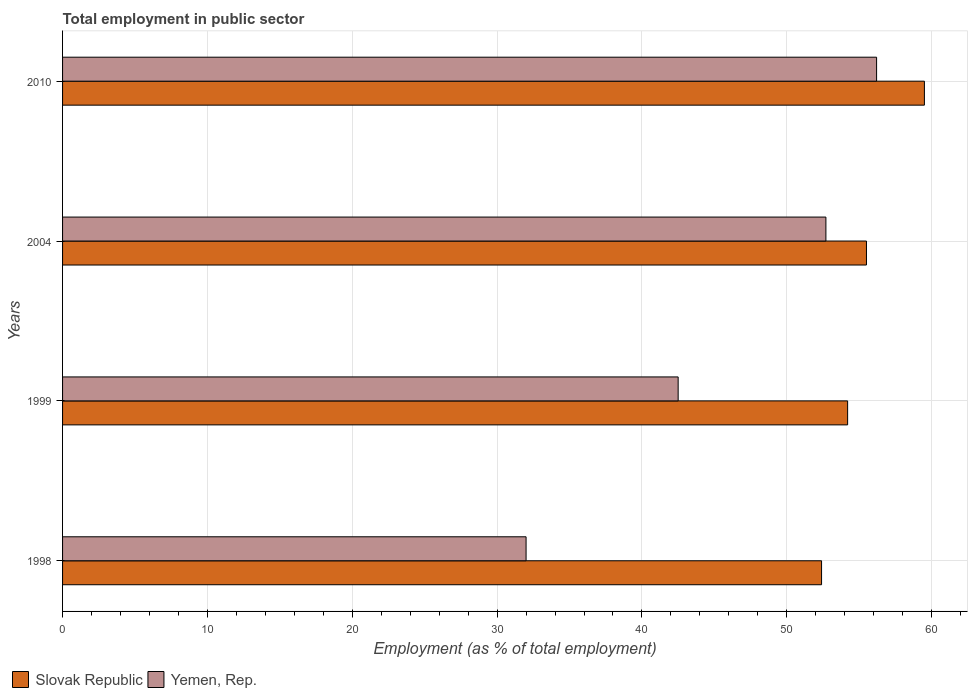How many groups of bars are there?
Your response must be concise. 4. Are the number of bars per tick equal to the number of legend labels?
Offer a terse response. Yes. How many bars are there on the 3rd tick from the bottom?
Ensure brevity in your answer.  2. What is the label of the 2nd group of bars from the top?
Provide a succinct answer. 2004. What is the employment in public sector in Slovak Republic in 2004?
Provide a succinct answer. 55.5. Across all years, what is the maximum employment in public sector in Slovak Republic?
Offer a very short reply. 59.5. Across all years, what is the minimum employment in public sector in Slovak Republic?
Keep it short and to the point. 52.4. In which year was the employment in public sector in Yemen, Rep. minimum?
Offer a very short reply. 1998. What is the total employment in public sector in Yemen, Rep. in the graph?
Your answer should be very brief. 183.4. What is the difference between the employment in public sector in Slovak Republic in 1999 and that in 2004?
Make the answer very short. -1.3. What is the difference between the employment in public sector in Yemen, Rep. in 2004 and the employment in public sector in Slovak Republic in 2010?
Give a very brief answer. -6.8. What is the average employment in public sector in Slovak Republic per year?
Offer a very short reply. 55.4. In the year 1998, what is the difference between the employment in public sector in Slovak Republic and employment in public sector in Yemen, Rep.?
Provide a succinct answer. 20.4. What is the ratio of the employment in public sector in Slovak Republic in 1998 to that in 2004?
Your answer should be compact. 0.94. What is the difference between the highest and the lowest employment in public sector in Slovak Republic?
Keep it short and to the point. 7.1. In how many years, is the employment in public sector in Slovak Republic greater than the average employment in public sector in Slovak Republic taken over all years?
Keep it short and to the point. 2. Is the sum of the employment in public sector in Yemen, Rep. in 1999 and 2010 greater than the maximum employment in public sector in Slovak Republic across all years?
Give a very brief answer. Yes. What does the 2nd bar from the top in 1998 represents?
Your response must be concise. Slovak Republic. What does the 1st bar from the bottom in 2010 represents?
Your answer should be very brief. Slovak Republic. How many years are there in the graph?
Give a very brief answer. 4. What is the difference between two consecutive major ticks on the X-axis?
Your answer should be very brief. 10. Are the values on the major ticks of X-axis written in scientific E-notation?
Provide a succinct answer. No. What is the title of the graph?
Provide a short and direct response. Total employment in public sector. What is the label or title of the X-axis?
Provide a short and direct response. Employment (as % of total employment). What is the Employment (as % of total employment) of Slovak Republic in 1998?
Your answer should be compact. 52.4. What is the Employment (as % of total employment) in Slovak Republic in 1999?
Offer a very short reply. 54.2. What is the Employment (as % of total employment) in Yemen, Rep. in 1999?
Offer a terse response. 42.5. What is the Employment (as % of total employment) in Slovak Republic in 2004?
Offer a terse response. 55.5. What is the Employment (as % of total employment) of Yemen, Rep. in 2004?
Give a very brief answer. 52.7. What is the Employment (as % of total employment) in Slovak Republic in 2010?
Provide a succinct answer. 59.5. What is the Employment (as % of total employment) in Yemen, Rep. in 2010?
Offer a terse response. 56.2. Across all years, what is the maximum Employment (as % of total employment) in Slovak Republic?
Provide a succinct answer. 59.5. Across all years, what is the maximum Employment (as % of total employment) of Yemen, Rep.?
Ensure brevity in your answer.  56.2. Across all years, what is the minimum Employment (as % of total employment) of Slovak Republic?
Keep it short and to the point. 52.4. Across all years, what is the minimum Employment (as % of total employment) of Yemen, Rep.?
Provide a short and direct response. 32. What is the total Employment (as % of total employment) in Slovak Republic in the graph?
Offer a very short reply. 221.6. What is the total Employment (as % of total employment) of Yemen, Rep. in the graph?
Offer a very short reply. 183.4. What is the difference between the Employment (as % of total employment) of Slovak Republic in 1998 and that in 1999?
Your response must be concise. -1.8. What is the difference between the Employment (as % of total employment) in Slovak Republic in 1998 and that in 2004?
Ensure brevity in your answer.  -3.1. What is the difference between the Employment (as % of total employment) in Yemen, Rep. in 1998 and that in 2004?
Your answer should be compact. -20.7. What is the difference between the Employment (as % of total employment) in Slovak Republic in 1998 and that in 2010?
Keep it short and to the point. -7.1. What is the difference between the Employment (as % of total employment) of Yemen, Rep. in 1998 and that in 2010?
Ensure brevity in your answer.  -24.2. What is the difference between the Employment (as % of total employment) in Yemen, Rep. in 1999 and that in 2004?
Make the answer very short. -10.2. What is the difference between the Employment (as % of total employment) of Yemen, Rep. in 1999 and that in 2010?
Keep it short and to the point. -13.7. What is the difference between the Employment (as % of total employment) in Yemen, Rep. in 2004 and that in 2010?
Your answer should be very brief. -3.5. What is the difference between the Employment (as % of total employment) of Slovak Republic in 1998 and the Employment (as % of total employment) of Yemen, Rep. in 1999?
Provide a short and direct response. 9.9. What is the average Employment (as % of total employment) of Slovak Republic per year?
Provide a short and direct response. 55.4. What is the average Employment (as % of total employment) of Yemen, Rep. per year?
Offer a terse response. 45.85. In the year 1998, what is the difference between the Employment (as % of total employment) in Slovak Republic and Employment (as % of total employment) in Yemen, Rep.?
Ensure brevity in your answer.  20.4. In the year 2004, what is the difference between the Employment (as % of total employment) of Slovak Republic and Employment (as % of total employment) of Yemen, Rep.?
Provide a short and direct response. 2.8. What is the ratio of the Employment (as % of total employment) in Slovak Republic in 1998 to that in 1999?
Ensure brevity in your answer.  0.97. What is the ratio of the Employment (as % of total employment) of Yemen, Rep. in 1998 to that in 1999?
Ensure brevity in your answer.  0.75. What is the ratio of the Employment (as % of total employment) of Slovak Republic in 1998 to that in 2004?
Offer a very short reply. 0.94. What is the ratio of the Employment (as % of total employment) in Yemen, Rep. in 1998 to that in 2004?
Offer a very short reply. 0.61. What is the ratio of the Employment (as % of total employment) in Slovak Republic in 1998 to that in 2010?
Give a very brief answer. 0.88. What is the ratio of the Employment (as % of total employment) in Yemen, Rep. in 1998 to that in 2010?
Your response must be concise. 0.57. What is the ratio of the Employment (as % of total employment) of Slovak Republic in 1999 to that in 2004?
Provide a succinct answer. 0.98. What is the ratio of the Employment (as % of total employment) in Yemen, Rep. in 1999 to that in 2004?
Give a very brief answer. 0.81. What is the ratio of the Employment (as % of total employment) in Slovak Republic in 1999 to that in 2010?
Your response must be concise. 0.91. What is the ratio of the Employment (as % of total employment) of Yemen, Rep. in 1999 to that in 2010?
Your answer should be compact. 0.76. What is the ratio of the Employment (as % of total employment) of Slovak Republic in 2004 to that in 2010?
Your answer should be compact. 0.93. What is the ratio of the Employment (as % of total employment) of Yemen, Rep. in 2004 to that in 2010?
Provide a succinct answer. 0.94. What is the difference between the highest and the second highest Employment (as % of total employment) in Slovak Republic?
Your answer should be very brief. 4. What is the difference between the highest and the second highest Employment (as % of total employment) in Yemen, Rep.?
Your answer should be compact. 3.5. What is the difference between the highest and the lowest Employment (as % of total employment) of Yemen, Rep.?
Your response must be concise. 24.2. 